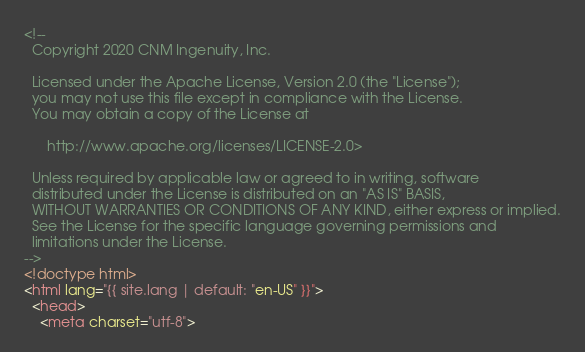Convert code to text. <code><loc_0><loc_0><loc_500><loc_500><_HTML_><!--
  Copyright 2020 CNM Ingenuity, Inc.

  Licensed under the Apache License, Version 2.0 (the "License");
  you may not use this file except in compliance with the License.
  You may obtain a copy of the License at

      http://www.apache.org/licenses/LICENSE-2.0>

  Unless required by applicable law or agreed to in writing, software
  distributed under the License is distributed on an "AS IS" BASIS,
  WITHOUT WARRANTIES OR CONDITIONS OF ANY KIND, either express or implied.
  See the License for the specific language governing permissions and
  limitations under the License.
-->
<!doctype html>
<html lang="{{ site.lang | default: "en-US" }}">
  <head>
    <meta charset="utf-8"></code> 